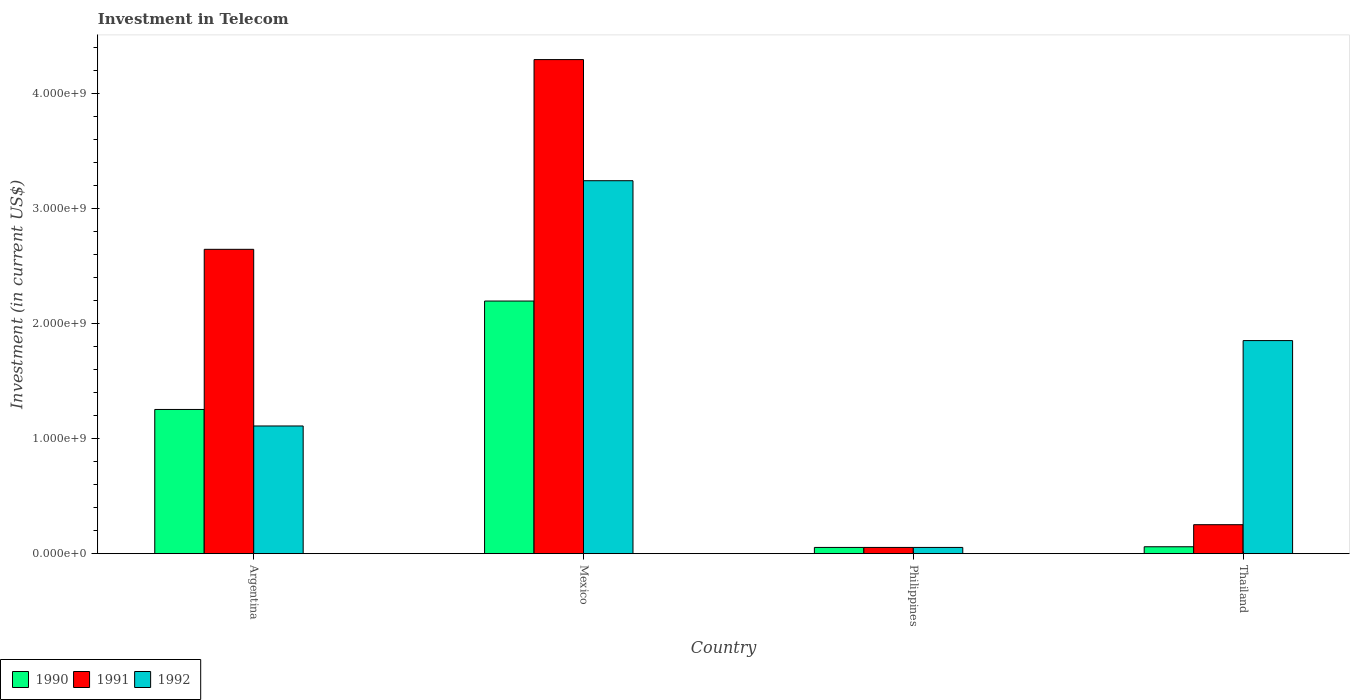How many different coloured bars are there?
Give a very brief answer. 3. How many groups of bars are there?
Offer a terse response. 4. How many bars are there on the 1st tick from the left?
Provide a short and direct response. 3. How many bars are there on the 4th tick from the right?
Keep it short and to the point. 3. What is the label of the 4th group of bars from the left?
Your answer should be very brief. Thailand. What is the amount invested in telecom in 1990 in Mexico?
Offer a terse response. 2.20e+09. Across all countries, what is the maximum amount invested in telecom in 1992?
Make the answer very short. 3.24e+09. Across all countries, what is the minimum amount invested in telecom in 1991?
Your answer should be compact. 5.42e+07. In which country was the amount invested in telecom in 1991 minimum?
Ensure brevity in your answer.  Philippines. What is the total amount invested in telecom in 1990 in the graph?
Provide a short and direct response. 3.57e+09. What is the difference between the amount invested in telecom in 1991 in Argentina and that in Thailand?
Provide a succinct answer. 2.40e+09. What is the difference between the amount invested in telecom in 1990 in Argentina and the amount invested in telecom in 1992 in Philippines?
Your response must be concise. 1.20e+09. What is the average amount invested in telecom in 1992 per country?
Offer a very short reply. 1.57e+09. What is the difference between the amount invested in telecom of/in 1990 and amount invested in telecom of/in 1992 in Argentina?
Keep it short and to the point. 1.44e+08. In how many countries, is the amount invested in telecom in 1991 greater than 1200000000 US$?
Keep it short and to the point. 2. What is the ratio of the amount invested in telecom in 1990 in Argentina to that in Thailand?
Offer a terse response. 20.91. What is the difference between the highest and the second highest amount invested in telecom in 1990?
Offer a terse response. 2.14e+09. What is the difference between the highest and the lowest amount invested in telecom in 1992?
Ensure brevity in your answer.  3.19e+09. In how many countries, is the amount invested in telecom in 1990 greater than the average amount invested in telecom in 1990 taken over all countries?
Give a very brief answer. 2. Is the sum of the amount invested in telecom in 1992 in Argentina and Thailand greater than the maximum amount invested in telecom in 1990 across all countries?
Provide a short and direct response. Yes. How many bars are there?
Give a very brief answer. 12. Are all the bars in the graph horizontal?
Provide a succinct answer. No. How many countries are there in the graph?
Ensure brevity in your answer.  4. What is the difference between two consecutive major ticks on the Y-axis?
Provide a short and direct response. 1.00e+09. Does the graph contain any zero values?
Provide a succinct answer. No. Does the graph contain grids?
Give a very brief answer. No. Where does the legend appear in the graph?
Offer a terse response. Bottom left. What is the title of the graph?
Your answer should be compact. Investment in Telecom. Does "1969" appear as one of the legend labels in the graph?
Ensure brevity in your answer.  No. What is the label or title of the Y-axis?
Make the answer very short. Investment (in current US$). What is the Investment (in current US$) of 1990 in Argentina?
Your answer should be very brief. 1.25e+09. What is the Investment (in current US$) in 1991 in Argentina?
Provide a short and direct response. 2.65e+09. What is the Investment (in current US$) in 1992 in Argentina?
Your answer should be compact. 1.11e+09. What is the Investment (in current US$) in 1990 in Mexico?
Your answer should be very brief. 2.20e+09. What is the Investment (in current US$) of 1991 in Mexico?
Offer a terse response. 4.30e+09. What is the Investment (in current US$) in 1992 in Mexico?
Offer a very short reply. 3.24e+09. What is the Investment (in current US$) in 1990 in Philippines?
Keep it short and to the point. 5.42e+07. What is the Investment (in current US$) of 1991 in Philippines?
Provide a short and direct response. 5.42e+07. What is the Investment (in current US$) in 1992 in Philippines?
Offer a terse response. 5.42e+07. What is the Investment (in current US$) of 1990 in Thailand?
Provide a short and direct response. 6.00e+07. What is the Investment (in current US$) in 1991 in Thailand?
Your response must be concise. 2.52e+08. What is the Investment (in current US$) in 1992 in Thailand?
Your answer should be compact. 1.85e+09. Across all countries, what is the maximum Investment (in current US$) of 1990?
Provide a short and direct response. 2.20e+09. Across all countries, what is the maximum Investment (in current US$) of 1991?
Give a very brief answer. 4.30e+09. Across all countries, what is the maximum Investment (in current US$) of 1992?
Your answer should be very brief. 3.24e+09. Across all countries, what is the minimum Investment (in current US$) in 1990?
Your response must be concise. 5.42e+07. Across all countries, what is the minimum Investment (in current US$) in 1991?
Offer a terse response. 5.42e+07. Across all countries, what is the minimum Investment (in current US$) in 1992?
Your answer should be very brief. 5.42e+07. What is the total Investment (in current US$) of 1990 in the graph?
Give a very brief answer. 3.57e+09. What is the total Investment (in current US$) of 1991 in the graph?
Give a very brief answer. 7.25e+09. What is the total Investment (in current US$) of 1992 in the graph?
Provide a succinct answer. 6.26e+09. What is the difference between the Investment (in current US$) in 1990 in Argentina and that in Mexico?
Provide a short and direct response. -9.43e+08. What is the difference between the Investment (in current US$) in 1991 in Argentina and that in Mexico?
Offer a terse response. -1.65e+09. What is the difference between the Investment (in current US$) in 1992 in Argentina and that in Mexico?
Your answer should be very brief. -2.13e+09. What is the difference between the Investment (in current US$) in 1990 in Argentina and that in Philippines?
Give a very brief answer. 1.20e+09. What is the difference between the Investment (in current US$) in 1991 in Argentina and that in Philippines?
Offer a very short reply. 2.59e+09. What is the difference between the Investment (in current US$) of 1992 in Argentina and that in Philippines?
Provide a short and direct response. 1.06e+09. What is the difference between the Investment (in current US$) of 1990 in Argentina and that in Thailand?
Provide a short and direct response. 1.19e+09. What is the difference between the Investment (in current US$) in 1991 in Argentina and that in Thailand?
Your answer should be very brief. 2.40e+09. What is the difference between the Investment (in current US$) in 1992 in Argentina and that in Thailand?
Provide a short and direct response. -7.43e+08. What is the difference between the Investment (in current US$) in 1990 in Mexico and that in Philippines?
Your answer should be compact. 2.14e+09. What is the difference between the Investment (in current US$) of 1991 in Mexico and that in Philippines?
Offer a terse response. 4.24e+09. What is the difference between the Investment (in current US$) of 1992 in Mexico and that in Philippines?
Give a very brief answer. 3.19e+09. What is the difference between the Investment (in current US$) in 1990 in Mexico and that in Thailand?
Provide a short and direct response. 2.14e+09. What is the difference between the Investment (in current US$) in 1991 in Mexico and that in Thailand?
Offer a very short reply. 4.05e+09. What is the difference between the Investment (in current US$) in 1992 in Mexico and that in Thailand?
Your answer should be compact. 1.39e+09. What is the difference between the Investment (in current US$) in 1990 in Philippines and that in Thailand?
Your answer should be compact. -5.80e+06. What is the difference between the Investment (in current US$) in 1991 in Philippines and that in Thailand?
Ensure brevity in your answer.  -1.98e+08. What is the difference between the Investment (in current US$) of 1992 in Philippines and that in Thailand?
Ensure brevity in your answer.  -1.80e+09. What is the difference between the Investment (in current US$) of 1990 in Argentina and the Investment (in current US$) of 1991 in Mexico?
Ensure brevity in your answer.  -3.04e+09. What is the difference between the Investment (in current US$) of 1990 in Argentina and the Investment (in current US$) of 1992 in Mexico?
Give a very brief answer. -1.99e+09. What is the difference between the Investment (in current US$) in 1991 in Argentina and the Investment (in current US$) in 1992 in Mexico?
Provide a short and direct response. -5.97e+08. What is the difference between the Investment (in current US$) in 1990 in Argentina and the Investment (in current US$) in 1991 in Philippines?
Offer a terse response. 1.20e+09. What is the difference between the Investment (in current US$) of 1990 in Argentina and the Investment (in current US$) of 1992 in Philippines?
Your response must be concise. 1.20e+09. What is the difference between the Investment (in current US$) of 1991 in Argentina and the Investment (in current US$) of 1992 in Philippines?
Offer a terse response. 2.59e+09. What is the difference between the Investment (in current US$) of 1990 in Argentina and the Investment (in current US$) of 1991 in Thailand?
Provide a short and direct response. 1.00e+09. What is the difference between the Investment (in current US$) in 1990 in Argentina and the Investment (in current US$) in 1992 in Thailand?
Your answer should be very brief. -5.99e+08. What is the difference between the Investment (in current US$) of 1991 in Argentina and the Investment (in current US$) of 1992 in Thailand?
Provide a succinct answer. 7.94e+08. What is the difference between the Investment (in current US$) of 1990 in Mexico and the Investment (in current US$) of 1991 in Philippines?
Give a very brief answer. 2.14e+09. What is the difference between the Investment (in current US$) in 1990 in Mexico and the Investment (in current US$) in 1992 in Philippines?
Make the answer very short. 2.14e+09. What is the difference between the Investment (in current US$) in 1991 in Mexico and the Investment (in current US$) in 1992 in Philippines?
Make the answer very short. 4.24e+09. What is the difference between the Investment (in current US$) in 1990 in Mexico and the Investment (in current US$) in 1991 in Thailand?
Provide a short and direct response. 1.95e+09. What is the difference between the Investment (in current US$) in 1990 in Mexico and the Investment (in current US$) in 1992 in Thailand?
Ensure brevity in your answer.  3.44e+08. What is the difference between the Investment (in current US$) in 1991 in Mexico and the Investment (in current US$) in 1992 in Thailand?
Ensure brevity in your answer.  2.44e+09. What is the difference between the Investment (in current US$) in 1990 in Philippines and the Investment (in current US$) in 1991 in Thailand?
Your answer should be compact. -1.98e+08. What is the difference between the Investment (in current US$) of 1990 in Philippines and the Investment (in current US$) of 1992 in Thailand?
Your response must be concise. -1.80e+09. What is the difference between the Investment (in current US$) of 1991 in Philippines and the Investment (in current US$) of 1992 in Thailand?
Offer a very short reply. -1.80e+09. What is the average Investment (in current US$) of 1990 per country?
Make the answer very short. 8.92e+08. What is the average Investment (in current US$) in 1991 per country?
Give a very brief answer. 1.81e+09. What is the average Investment (in current US$) in 1992 per country?
Offer a very short reply. 1.57e+09. What is the difference between the Investment (in current US$) of 1990 and Investment (in current US$) of 1991 in Argentina?
Your answer should be compact. -1.39e+09. What is the difference between the Investment (in current US$) of 1990 and Investment (in current US$) of 1992 in Argentina?
Offer a very short reply. 1.44e+08. What is the difference between the Investment (in current US$) in 1991 and Investment (in current US$) in 1992 in Argentina?
Ensure brevity in your answer.  1.54e+09. What is the difference between the Investment (in current US$) of 1990 and Investment (in current US$) of 1991 in Mexico?
Provide a short and direct response. -2.10e+09. What is the difference between the Investment (in current US$) in 1990 and Investment (in current US$) in 1992 in Mexico?
Give a very brief answer. -1.05e+09. What is the difference between the Investment (in current US$) of 1991 and Investment (in current US$) of 1992 in Mexico?
Keep it short and to the point. 1.05e+09. What is the difference between the Investment (in current US$) in 1990 and Investment (in current US$) in 1991 in Philippines?
Give a very brief answer. 0. What is the difference between the Investment (in current US$) in 1990 and Investment (in current US$) in 1992 in Philippines?
Make the answer very short. 0. What is the difference between the Investment (in current US$) in 1990 and Investment (in current US$) in 1991 in Thailand?
Make the answer very short. -1.92e+08. What is the difference between the Investment (in current US$) in 1990 and Investment (in current US$) in 1992 in Thailand?
Give a very brief answer. -1.79e+09. What is the difference between the Investment (in current US$) of 1991 and Investment (in current US$) of 1992 in Thailand?
Your response must be concise. -1.60e+09. What is the ratio of the Investment (in current US$) in 1990 in Argentina to that in Mexico?
Offer a terse response. 0.57. What is the ratio of the Investment (in current US$) in 1991 in Argentina to that in Mexico?
Keep it short and to the point. 0.62. What is the ratio of the Investment (in current US$) in 1992 in Argentina to that in Mexico?
Your response must be concise. 0.34. What is the ratio of the Investment (in current US$) of 1990 in Argentina to that in Philippines?
Your response must be concise. 23.15. What is the ratio of the Investment (in current US$) of 1991 in Argentina to that in Philippines?
Provide a short and direct response. 48.86. What is the ratio of the Investment (in current US$) of 1992 in Argentina to that in Philippines?
Offer a terse response. 20.5. What is the ratio of the Investment (in current US$) of 1990 in Argentina to that in Thailand?
Make the answer very short. 20.91. What is the ratio of the Investment (in current US$) of 1991 in Argentina to that in Thailand?
Ensure brevity in your answer.  10.51. What is the ratio of the Investment (in current US$) in 1992 in Argentina to that in Thailand?
Offer a terse response. 0.6. What is the ratio of the Investment (in current US$) in 1990 in Mexico to that in Philippines?
Your answer should be compact. 40.55. What is the ratio of the Investment (in current US$) of 1991 in Mexico to that in Philippines?
Provide a short and direct response. 79.32. What is the ratio of the Investment (in current US$) in 1992 in Mexico to that in Philippines?
Your answer should be very brief. 59.87. What is the ratio of the Investment (in current US$) in 1990 in Mexico to that in Thailand?
Make the answer very short. 36.63. What is the ratio of the Investment (in current US$) of 1991 in Mexico to that in Thailand?
Provide a succinct answer. 17.06. What is the ratio of the Investment (in current US$) in 1992 in Mexico to that in Thailand?
Make the answer very short. 1.75. What is the ratio of the Investment (in current US$) of 1990 in Philippines to that in Thailand?
Provide a succinct answer. 0.9. What is the ratio of the Investment (in current US$) in 1991 in Philippines to that in Thailand?
Your response must be concise. 0.22. What is the ratio of the Investment (in current US$) of 1992 in Philippines to that in Thailand?
Make the answer very short. 0.03. What is the difference between the highest and the second highest Investment (in current US$) of 1990?
Keep it short and to the point. 9.43e+08. What is the difference between the highest and the second highest Investment (in current US$) in 1991?
Offer a terse response. 1.65e+09. What is the difference between the highest and the second highest Investment (in current US$) in 1992?
Give a very brief answer. 1.39e+09. What is the difference between the highest and the lowest Investment (in current US$) in 1990?
Give a very brief answer. 2.14e+09. What is the difference between the highest and the lowest Investment (in current US$) of 1991?
Offer a very short reply. 4.24e+09. What is the difference between the highest and the lowest Investment (in current US$) of 1992?
Ensure brevity in your answer.  3.19e+09. 